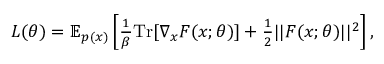Convert formula to latex. <formula><loc_0><loc_0><loc_500><loc_500>\begin{array} { r } { L ( \theta ) = \mathbb { E } _ { p ( x ) } \left [ \frac { 1 } { \beta } T r [ \nabla _ { x } F ( x ; \theta ) ] + \frac { 1 } { 2 } | | F ( x ; \theta ) | | ^ { 2 } \right ] , } \end{array}</formula> 